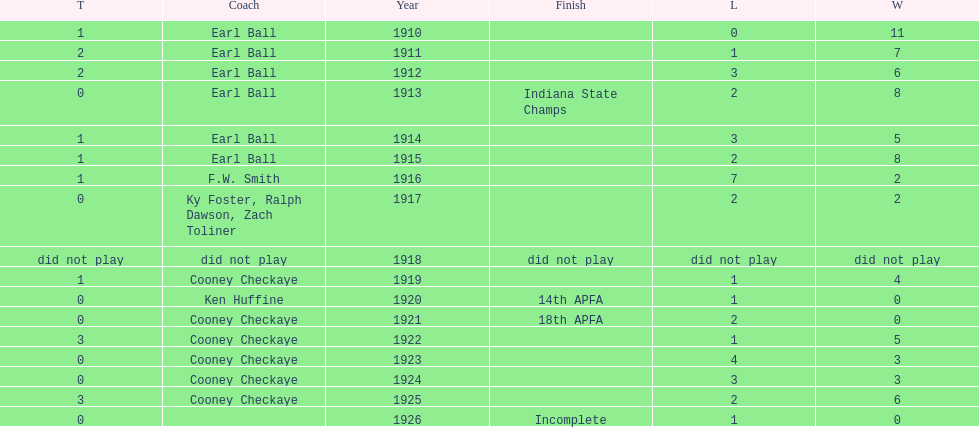The muncie flyers played from 1910 to 1925 in all but one of those years. which year did the flyers not play? 1918. Parse the full table. {'header': ['T', 'Coach', 'Year', 'Finish', 'L', 'W'], 'rows': [['1', 'Earl Ball', '1910', '', '0', '11'], ['2', 'Earl Ball', '1911', '', '1', '7'], ['2', 'Earl Ball', '1912', '', '3', '6'], ['0', 'Earl Ball', '1913', 'Indiana State Champs', '2', '8'], ['1', 'Earl Ball', '1914', '', '3', '5'], ['1', 'Earl Ball', '1915', '', '2', '8'], ['1', 'F.W. Smith', '1916', '', '7', '2'], ['0', 'Ky Foster, Ralph Dawson, Zach Toliner', '1917', '', '2', '2'], ['did not play', 'did not play', '1918', 'did not play', 'did not play', 'did not play'], ['1', 'Cooney Checkaye', '1919', '', '1', '4'], ['0', 'Ken Huffine', '1920', '14th APFA', '1', '0'], ['0', 'Cooney Checkaye', '1921', '18th APFA', '2', '0'], ['3', 'Cooney Checkaye', '1922', '', '1', '5'], ['0', 'Cooney Checkaye', '1923', '', '4', '3'], ['0', 'Cooney Checkaye', '1924', '', '3', '3'], ['3', 'Cooney Checkaye', '1925', '', '2', '6'], ['0', '', '1926', 'Incomplete', '1', '0']]} 